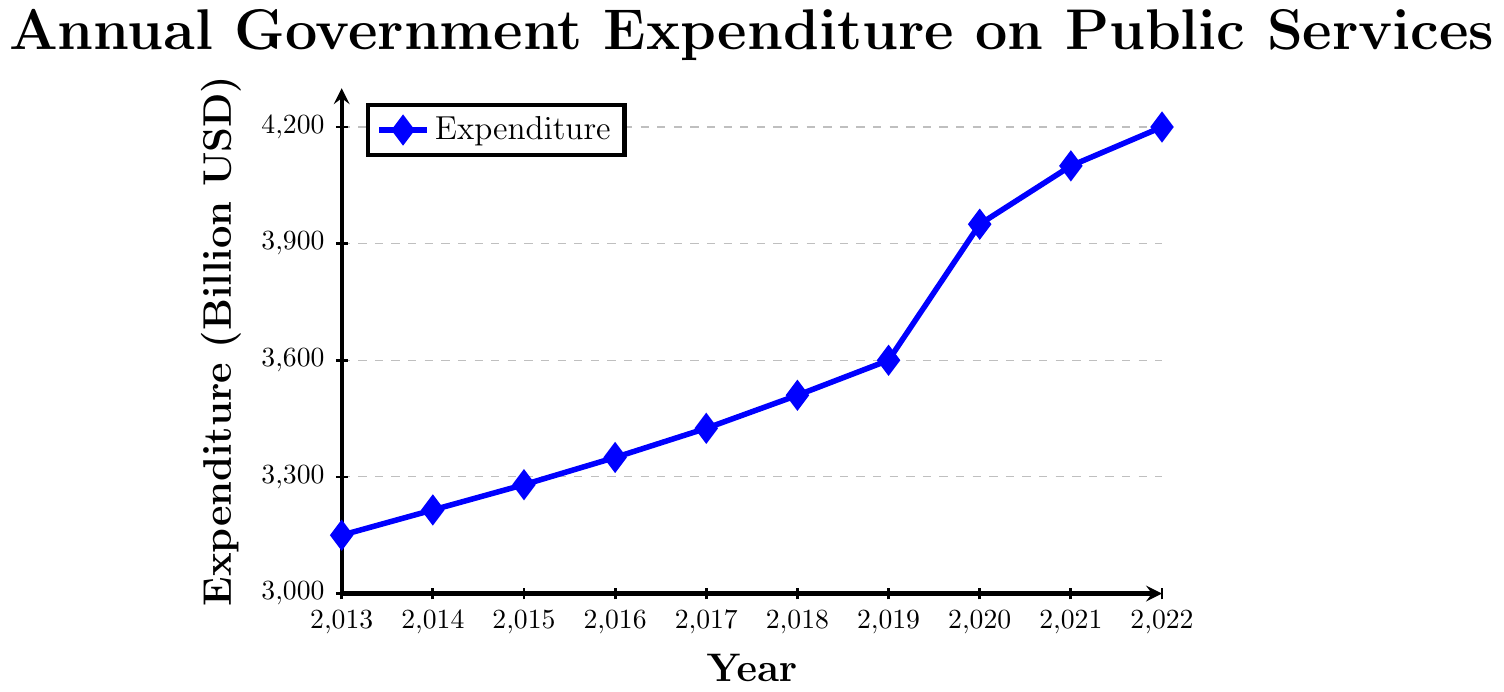What is the total government expenditure on public services from 2013 to 2016? Sum the expenditures for each of the years 2013 to 2016: 3150 + 3215 + 3280 + 3350 = 12995 billion USD
Answer: 12995 billion USD In which year did the government spend the most on public services? Look for the highest point on the expenditure line. The highest expenditure is 4200 billion USD in 2022
Answer: 2022 Which year experienced the highest increase in government expenditure compared to the previous year? Calculate the yearly differences: 
2014-2013 = 65, 2015-2014 = 65, 2016-2015 = 70, 2017-2016 = 75, 2018-2017 = 85, 2019-2018 = 90, 2020-2019 = 350, 2021-2020 = 150, 2022-2021 = 100. 
The highest increase is 350 billion USD from 2019 to 2020
Answer: 2020 What is the average annual government expenditure on public services over the past decade? Sum the expenditures for all years and divide by the number of years: (3150 + 3215 + 3280 + 3350 + 3425 + 3510 + 3600 + 3950 + 4100 + 4200) / 10 = 36280 / 10 = 3628 billion USD
Answer: 3628 billion USD How did the government expenditure in 2020 compare to the expenditure in 2015? Subtract the 2015 expenditure from the 2020 expenditure: 3950 - 3280 = 670 billion USD
Answer: 670 billion USD Is the trend of government expenditure on public services increasing or decreasing? Observe the general direction of the expenditure line from 2013 to 2022; it consistently rises, indicating an increasing trend
Answer: Increasing Between which consecutive years was the smallest increase in government expenditure observed? Calculate the yearly differences and find the smallest one: 
2014-2013 = 65, 2015-2014 = 65, 2016-2015 = 70, 2017-2016 = 75, 2018-2017 = 85, 2019-2018 = 90, 2020-2019 = 350, 2021-2020 = 150, 2022-2021 = 100. 
The smallest increase is 65 billion USD between 2013-2014 and 2014-2015
Answer: 2013-2014 and 2014-2015 By how much did the expenditure increase from the year 2016 to the year 2022? Subtract the 2016 expenditure from the 2022 expenditure: 4200 - 3350 = 850 billion USD
Answer: 850 billion USD 